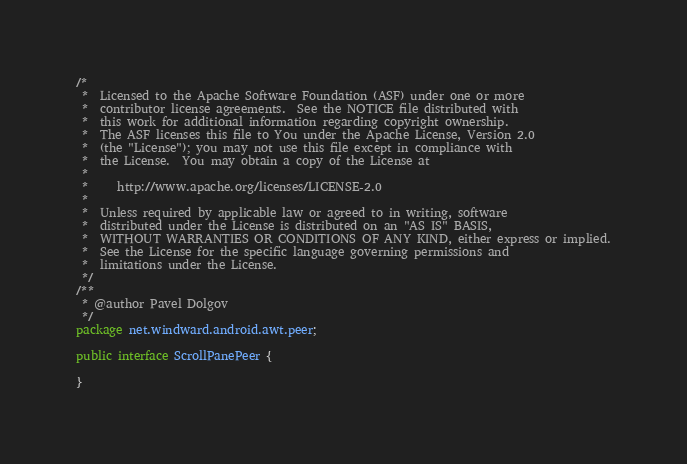<code> <loc_0><loc_0><loc_500><loc_500><_Java_>/*
 *  Licensed to the Apache Software Foundation (ASF) under one or more
 *  contributor license agreements.  See the NOTICE file distributed with
 *  this work for additional information regarding copyright ownership.
 *  The ASF licenses this file to You under the Apache License, Version 2.0
 *  (the "License"); you may not use this file except in compliance with
 *  the License.  You may obtain a copy of the License at
 *
 *     http://www.apache.org/licenses/LICENSE-2.0
 *
 *  Unless required by applicable law or agreed to in writing, software
 *  distributed under the License is distributed on an "AS IS" BASIS,
 *  WITHOUT WARRANTIES OR CONDITIONS OF ANY KIND, either express or implied.
 *  See the License for the specific language governing permissions and
 *  limitations under the License.
 */
/**
 * @author Pavel Dolgov
 */
package net.windward.android.awt.peer;

public interface ScrollPanePeer {

}
</code> 